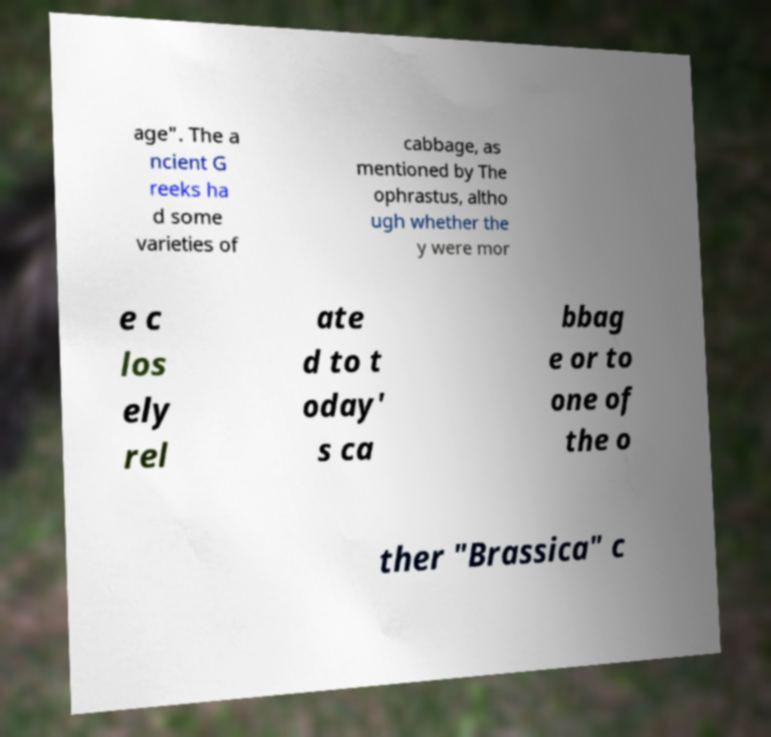There's text embedded in this image that I need extracted. Can you transcribe it verbatim? age". The a ncient G reeks ha d some varieties of cabbage, as mentioned by The ophrastus, altho ugh whether the y were mor e c los ely rel ate d to t oday' s ca bbag e or to one of the o ther "Brassica" c 